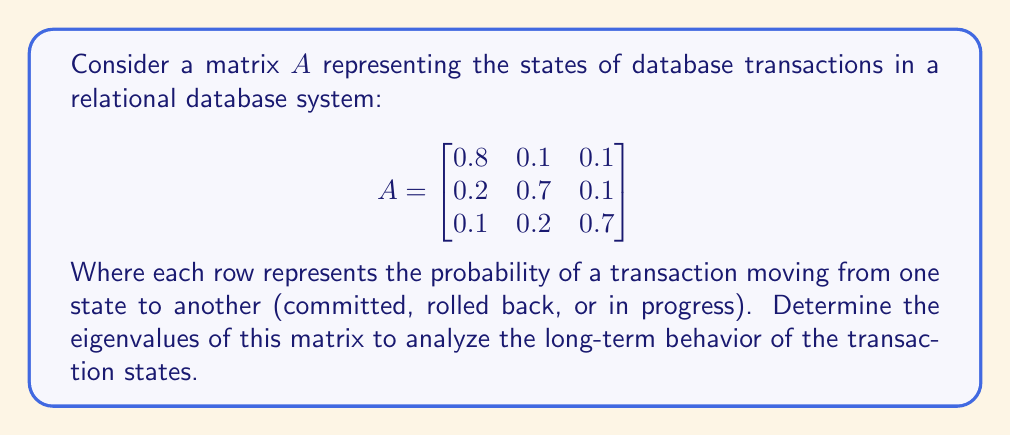Solve this math problem. To find the eigenvalues of matrix $A$, we need to solve the characteristic equation:

$det(A - \lambda I) = 0$

Where $I$ is the 3x3 identity matrix and $\lambda$ represents the eigenvalues.

Step 1: Set up the characteristic equation:

$$det\begin{pmatrix}
0.8-\lambda & 0.1 & 0.1 \\
0.2 & 0.7-\lambda & 0.1 \\
0.1 & 0.2 & 0.7-\lambda
\end{pmatrix} = 0$$

Step 2: Expand the determinant:

$(0.8-\lambda)[(0.7-\lambda)(0.7-\lambda) - 0.02] - 0.1[0.2(0.7-\lambda) - 0.1(0.1)] + 0.1[0.2(0.1) - 0.1(0.7-\lambda)] = 0$

Step 3: Simplify:

$(0.8-\lambda)(0.49 - 1.4\lambda + \lambda^2 - 0.02) - 0.1(0.14 - 0.2\lambda - 0.01) + 0.1(0.02 - 0.07 + 0.1\lambda) = 0$

Step 4: Expand and collect terms:

$\lambda^3 - 2.2\lambda^2 + 1.51\lambda - 0.322 = 0$

Step 5: Solve the cubic equation. This can be done using the cubic formula or numerical methods. The eigenvalues are:

$\lambda_1 = 1$
$\lambda_2 \approx 0.7$
$\lambda_3 \approx 0.5$

The eigenvalue $\lambda_1 = 1$ corresponds to the steady-state distribution of the transaction states, while $\lambda_2$ and $\lambda_3$ represent the rates of convergence to this steady state.
Answer: $\lambda_1 = 1$, $\lambda_2 \approx 0.7$, $\lambda_3 \approx 0.5$ 